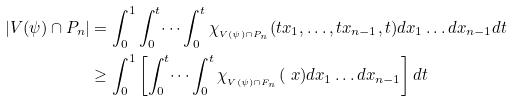<formula> <loc_0><loc_0><loc_500><loc_500>| V ( \psi ) \cap P _ { n } | & = \int _ { 0 } ^ { 1 } \int _ { 0 } ^ { t } \dots \int _ { 0 } ^ { t } \chi _ { _ { V ( \psi ) \cap P _ { n } } } ( t x _ { 1 } , \dots , t x _ { n - 1 } , t ) d x _ { 1 } \dots d x _ { n - 1 } d t \\ & \geq \int _ { 0 } ^ { 1 } \left [ \int _ { 0 } ^ { t } \dots \int _ { 0 } ^ { t } \chi _ { _ { V ( \psi ) \cap F _ { n } } } ( \ x ) d x _ { 1 } \dots d x _ { n - 1 } \right ] d t</formula> 